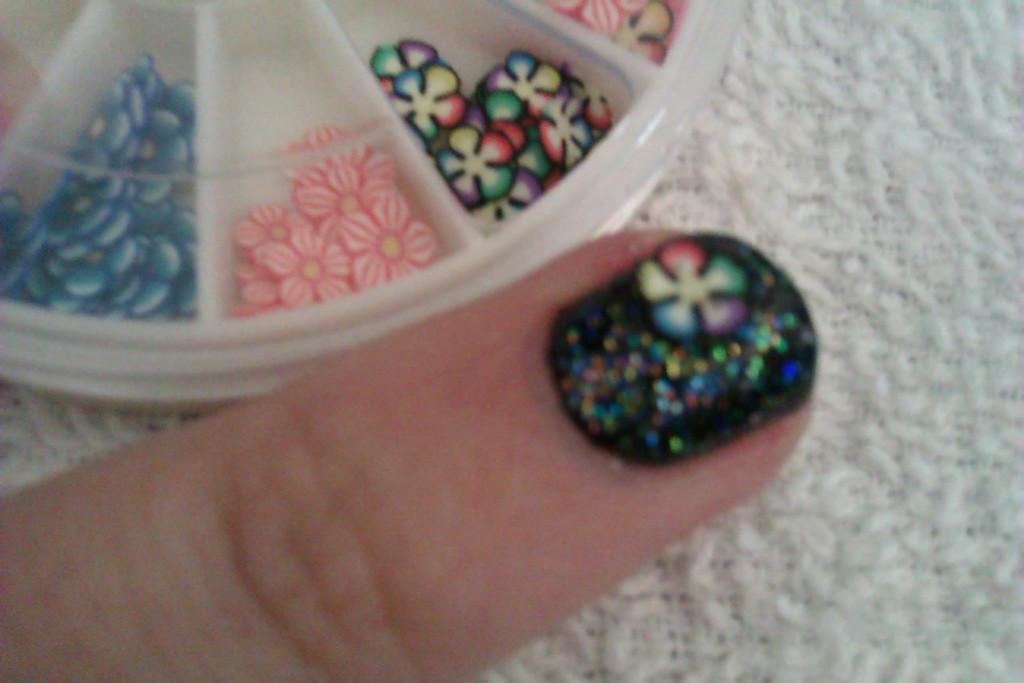What part of the body is visible in the image? There is a person's finger in the image. What type of material is present in the image? There is cloth in the image. What type of container is visible in the image? There is a box in the image. Can you describe the unspecified objects in the image? Unfortunately, the facts provided do not give any details about the unspecified objects in the image. What type of lipstick is the person wearing while reading at the seashore in the image? There is no person, lipstick, reading, or seashore present in the image; it only features a person's finger, cloth, a box, and some unspecified objects. 